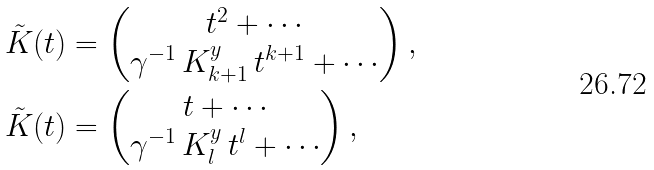<formula> <loc_0><loc_0><loc_500><loc_500>& \tilde { K } ( t ) = \begin{pmatrix} t ^ { 2 } + \cdots \\ \gamma ^ { - 1 } \, K _ { k + 1 } ^ { y } \, t ^ { k + 1 } + \cdots \end{pmatrix} , \\ & \tilde { K } ( t ) = \begin{pmatrix} t + \cdots \\ \gamma ^ { - 1 } \, K _ { l } ^ { y } \, t ^ { l } + \cdots \end{pmatrix} ,</formula> 